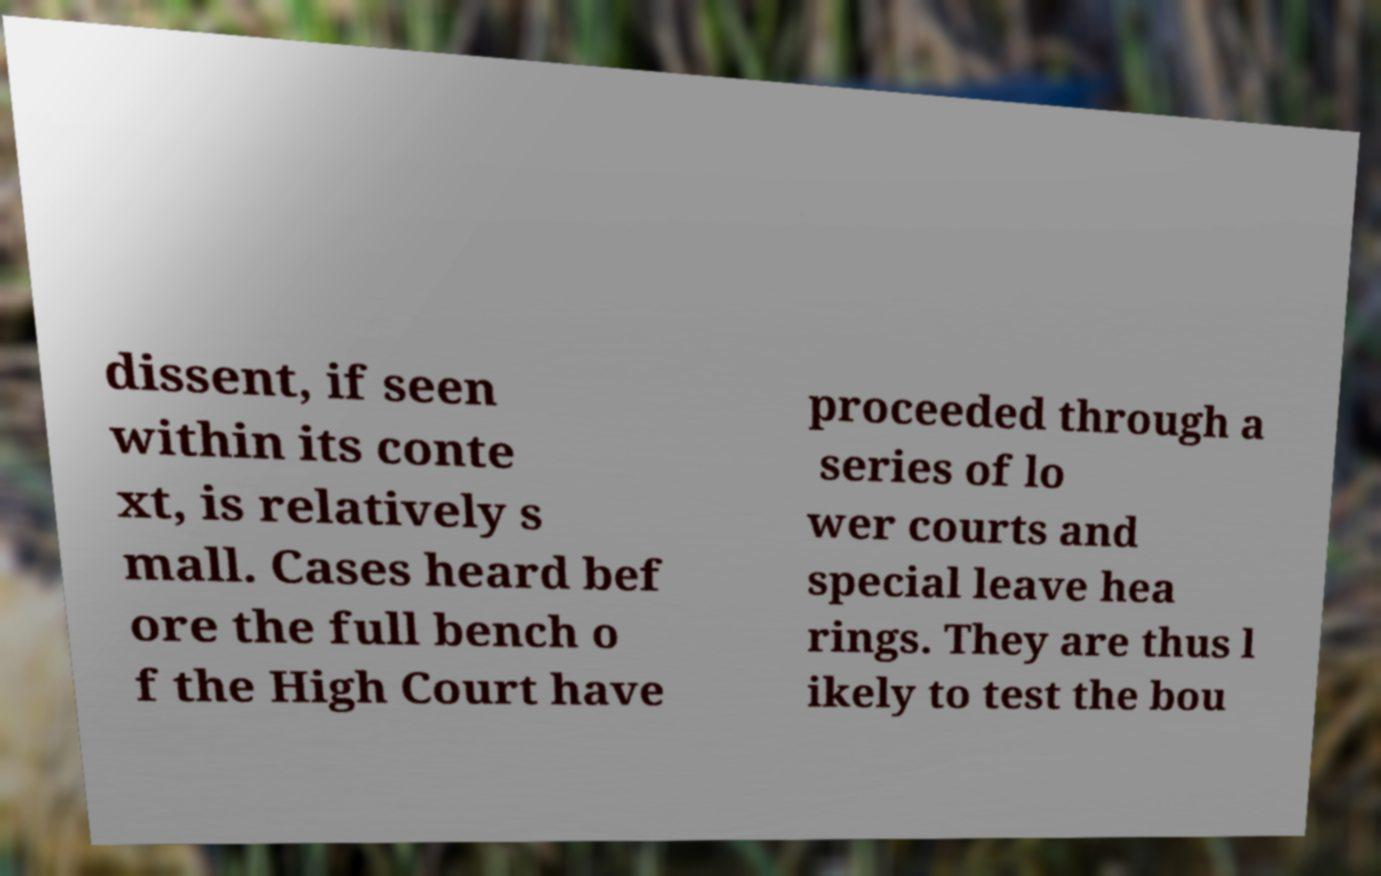Can you read and provide the text displayed in the image?This photo seems to have some interesting text. Can you extract and type it out for me? dissent, if seen within its conte xt, is relatively s mall. Cases heard bef ore the full bench o f the High Court have proceeded through a series of lo wer courts and special leave hea rings. They are thus l ikely to test the bou 